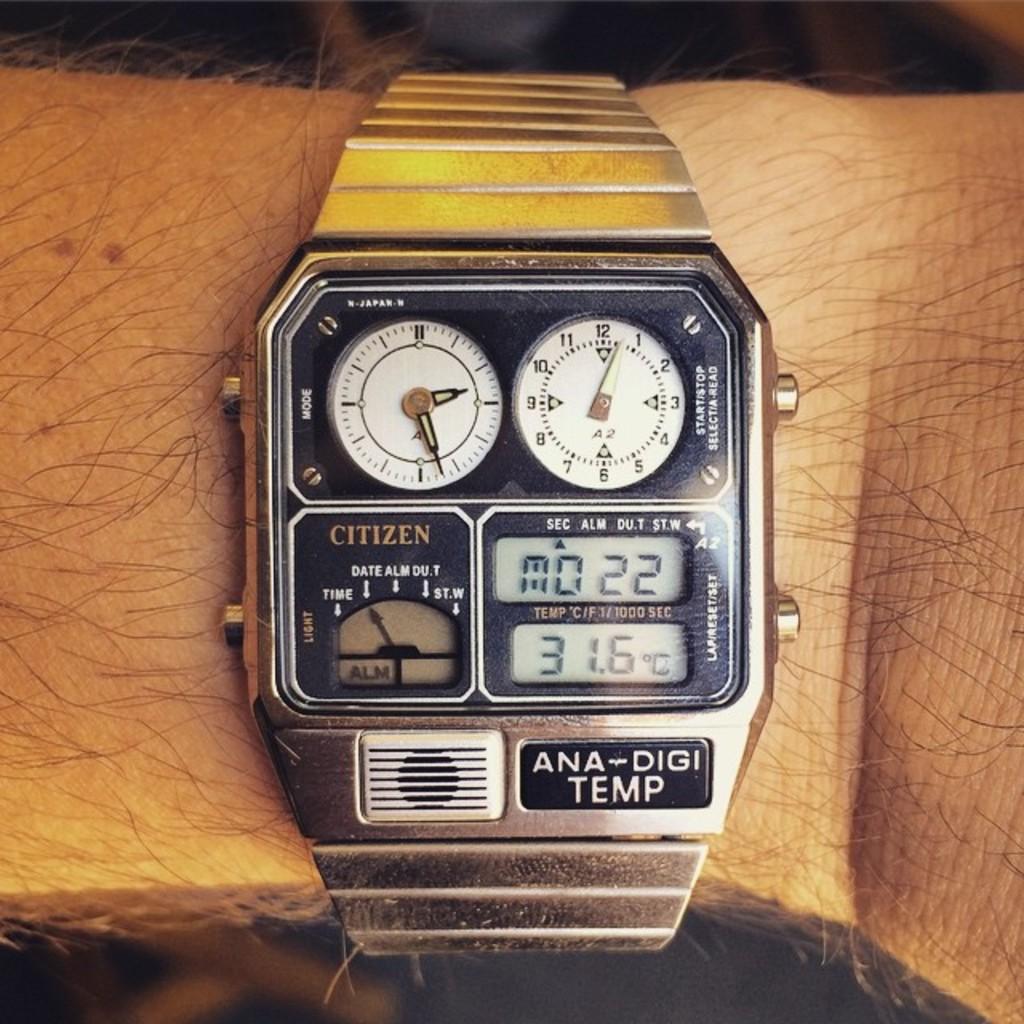What is the temperature?
Offer a terse response. 31.6 c. What kind of watch is this?
Offer a terse response. Citizen. 